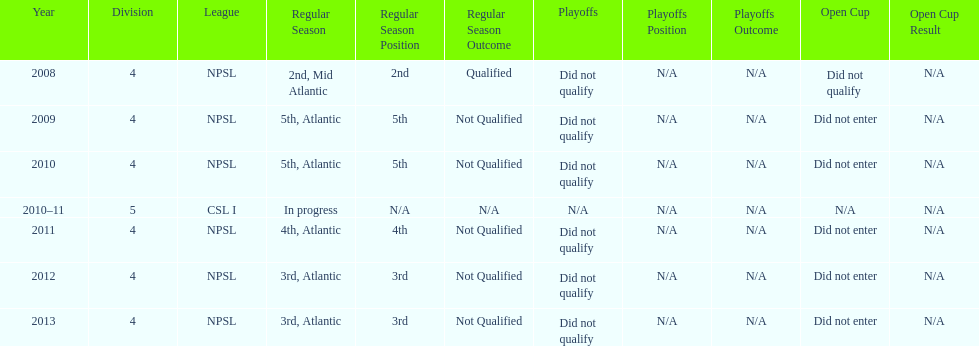I'm looking to parse the entire table for insights. Could you assist me with that? {'header': ['Year', 'Division', 'League', 'Regular Season', 'Regular Season Position', 'Regular Season Outcome', 'Playoffs', 'Playoffs Position', 'Playoffs Outcome', 'Open Cup', 'Open Cup Result'], 'rows': [['2008', '4', 'NPSL', '2nd, Mid Atlantic', '2nd', 'Qualified', 'Did not qualify', 'N/A', 'N/A', 'Did not qualify', 'N/A'], ['2009', '4', 'NPSL', '5th, Atlantic', '5th', 'Not Qualified', 'Did not qualify', 'N/A', 'N/A', 'Did not enter', 'N/A'], ['2010', '4', 'NPSL', '5th, Atlantic', '5th', 'Not Qualified', 'Did not qualify', 'N/A', 'N/A', 'Did not enter', 'N/A'], ['2010–11', '5', 'CSL I', 'In progress', 'N/A', 'N/A', 'N/A', 'N/A', 'N/A', 'N/A', 'N/A'], ['2011', '4', 'NPSL', '4th, Atlantic', '4th', 'Not Qualified', 'Did not qualify', 'N/A', 'N/A', 'Did not enter', 'N/A'], ['2012', '4', 'NPSL', '3rd, Atlantic', '3rd', 'Not Qualified', 'Did not qualify', 'N/A', 'N/A', 'Did not enter', 'N/A'], ['2013', '4', 'NPSL', '3rd, Atlantic', '3rd', 'Not Qualified', 'Did not qualify', 'N/A', 'N/A', 'Did not enter', 'N/A']]} How did they place the year after they were 4th in the regular season? 3rd. 